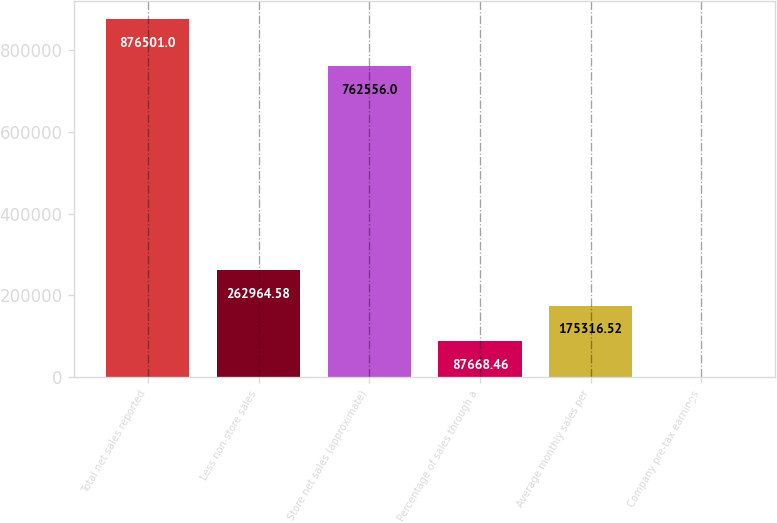Convert chart to OTSL. <chart><loc_0><loc_0><loc_500><loc_500><bar_chart><fcel>Total net sales reported<fcel>Less non-store sales<fcel>Store net sales (approximate)<fcel>Percentage of sales through a<fcel>Average monthly sales per<fcel>Company pre-tax earnings<nl><fcel>876501<fcel>262965<fcel>762556<fcel>87668.5<fcel>175317<fcel>20.4<nl></chart> 